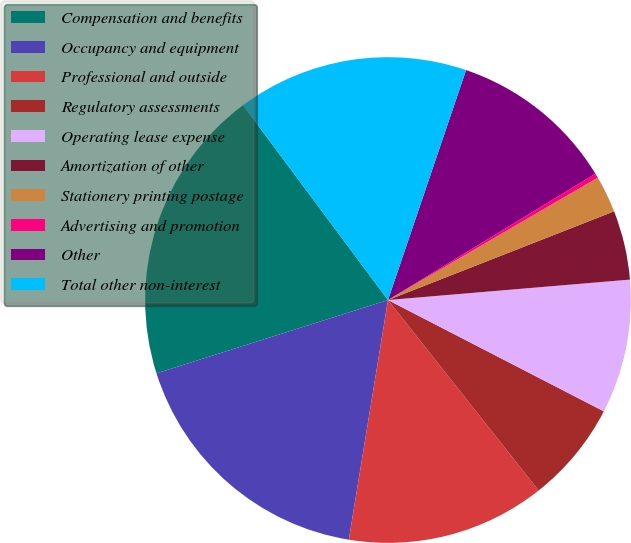Convert chart. <chart><loc_0><loc_0><loc_500><loc_500><pie_chart><fcel>Compensation and benefits<fcel>Occupancy and equipment<fcel>Professional and outside<fcel>Regulatory assessments<fcel>Operating lease expense<fcel>Amortization of other<fcel>Stationery printing postage<fcel>Advertising and promotion<fcel>Other<fcel>Total other non-interest<nl><fcel>19.7%<fcel>17.54%<fcel>13.23%<fcel>6.77%<fcel>8.92%<fcel>4.61%<fcel>2.46%<fcel>0.3%<fcel>11.08%<fcel>15.39%<nl></chart> 